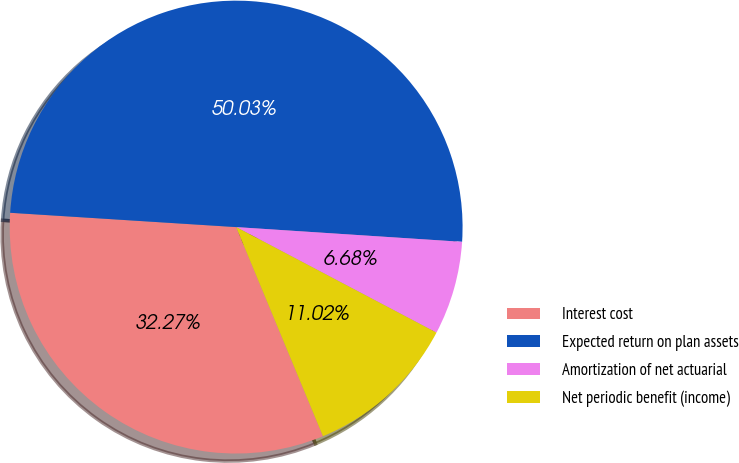Convert chart to OTSL. <chart><loc_0><loc_0><loc_500><loc_500><pie_chart><fcel>Interest cost<fcel>Expected return on plan assets<fcel>Amortization of net actuarial<fcel>Net periodic benefit (income)<nl><fcel>32.27%<fcel>50.03%<fcel>6.68%<fcel>11.02%<nl></chart> 